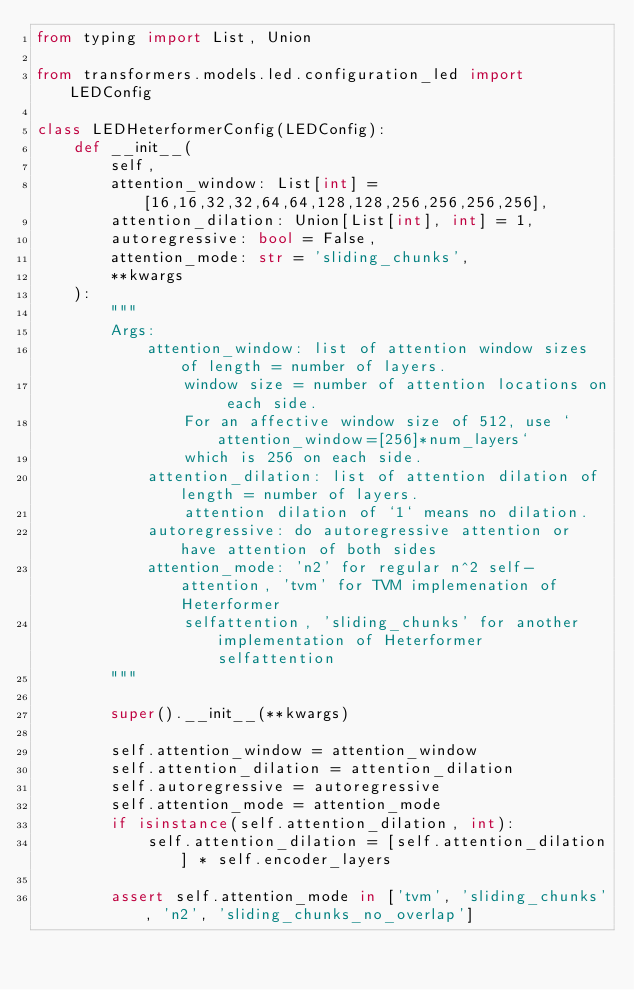<code> <loc_0><loc_0><loc_500><loc_500><_Python_>from typing import List, Union

from transformers.models.led.configuration_led import LEDConfig

class LEDHeterformerConfig(LEDConfig):
    def __init__(
        self, 
        attention_window: List[int] = [16,16,32,32,64,64,128,128,256,256,256,256], 
        attention_dilation: Union[List[int], int] = 1,
        autoregressive: bool = False, 
        attention_mode: str = 'sliding_chunks', 
        **kwargs
    ):
        """
        Args:
            attention_window: list of attention window sizes of length = number of layers.
                window size = number of attention locations on each side.
                For an affective window size of 512, use `attention_window=[256]*num_layers`
                which is 256 on each side.
            attention_dilation: list of attention dilation of length = number of layers.
                attention dilation of `1` means no dilation.
            autoregressive: do autoregressive attention or have attention of both sides
            attention_mode: 'n2' for regular n^2 self-attention, 'tvm' for TVM implemenation of Heterformer
                selfattention, 'sliding_chunks' for another implementation of Heterformer selfattention
        """

        super().__init__(**kwargs)

        self.attention_window = attention_window
        self.attention_dilation = attention_dilation
        self.autoregressive = autoregressive
        self.attention_mode = attention_mode
        if isinstance(self.attention_dilation, int):
            self.attention_dilation = [self.attention_dilation] * self.encoder_layers

        assert self.attention_mode in ['tvm', 'sliding_chunks', 'n2', 'sliding_chunks_no_overlap']

        </code> 